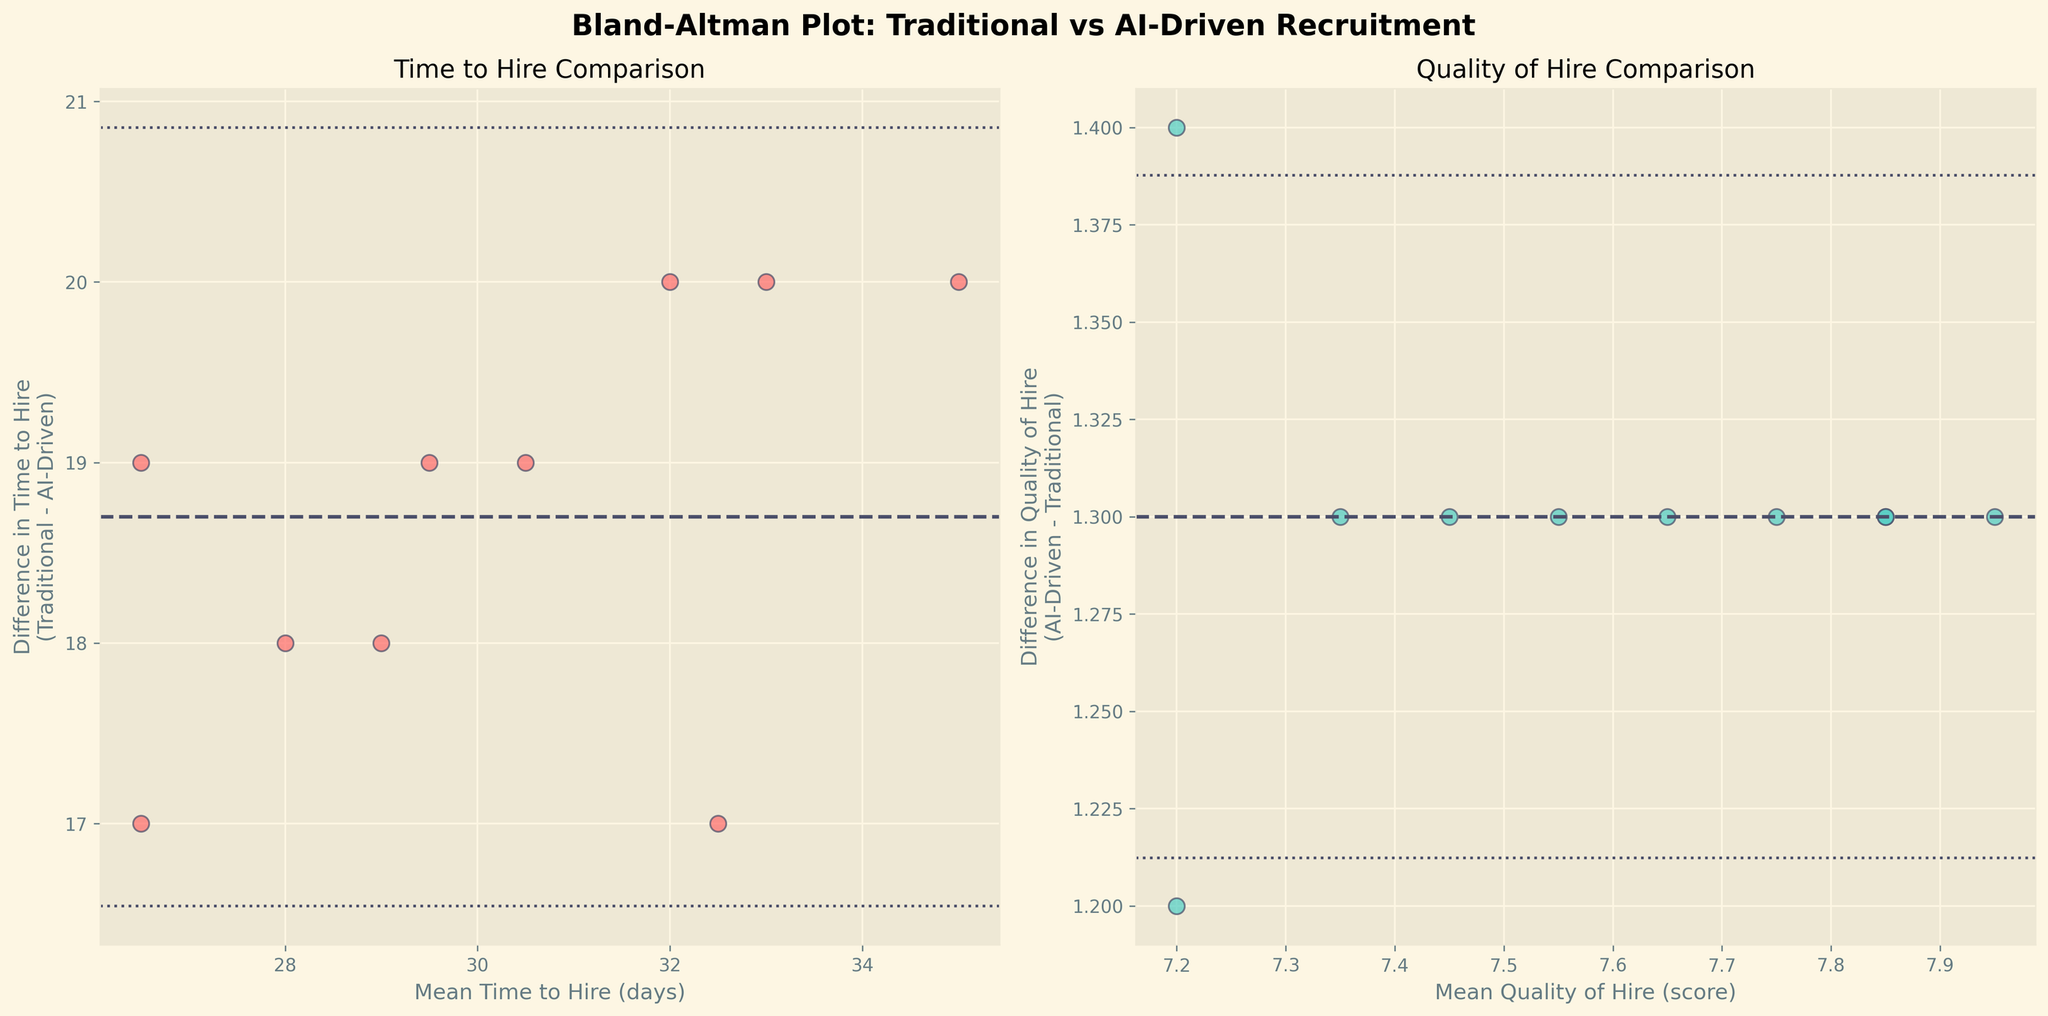What's the title of the figure? The title of a figure is typically located at the top or near the top of the plot. In this case, it reads "Bland-Altman Plot: Traditional vs AI-Driven Recruitment" in bold style.
Answer: Bland-Altman Plot: Traditional vs AI-Driven Recruitment How many data points are represented in each subplot? The number of data points is shown by the number of scattered points in each subplot. Counting the points, there are 10 data points in each subplot.
Answer: 10 Which subplot shows a comparison of time to hire? The subplot titles help to determine this. The subplot on the left has the title "Time to Hire Comparison", indicating it shows a comparison of time to hire.
Answer: Left subplot What color is used for the data points in the Quality of Hire comparison plot? The data points' color can be identified by observing the scattered points. In the right subplot, the data points are colored in a teal color.
Answer: Teal What is the mean difference in time to hire? The mean difference in time to hire is indicated by the dashed black line on the left subplot. It intersects the y-axis around 21 days.
Answer: 21 days What is the mean difference in the quality of hire? The mean difference in the quality of hire is indicated by the dashed black line on the right subplot. It intersects the y-axis around 1.4.
Answer: 1.4 Do any of the data points fall outside the 1.96 standard deviations in the Time to Hire plot? By inspecting the data points relative to the dotted lines representing ±1.96 standard deviations from the mean, we can see if any points lie outside these boundaries in the left subplot. None of the points do.
Answer: No Which method has the highest mean Quality of Hire when combining both recruitment methods? The mean Quality of Hire can be deduced from the right subplot by finding the data point with the highest mean value along the x-axis. This is around 7.95 for AngelList.
Answer: AngelList What does the x-axis represent in the left subplot? The x-axis labels help in identifying what it represents. In the left subplot, the x-axis is labeled "Mean Time to Hire (days)", indicating it represents the average time to hire in days.
Answer: Mean Time to Hire (days) What does the y-axis represent in the right subplot? The y-axis labels aid in determining what it represents. In the right subplot, the y-axis is labeled "Difference in Quality of Hire\n(AI-Driven - Traditional)", indicating it shows the difference between the AI-driven and traditional quality of hire.
Answer: Difference in Quality of Hire 